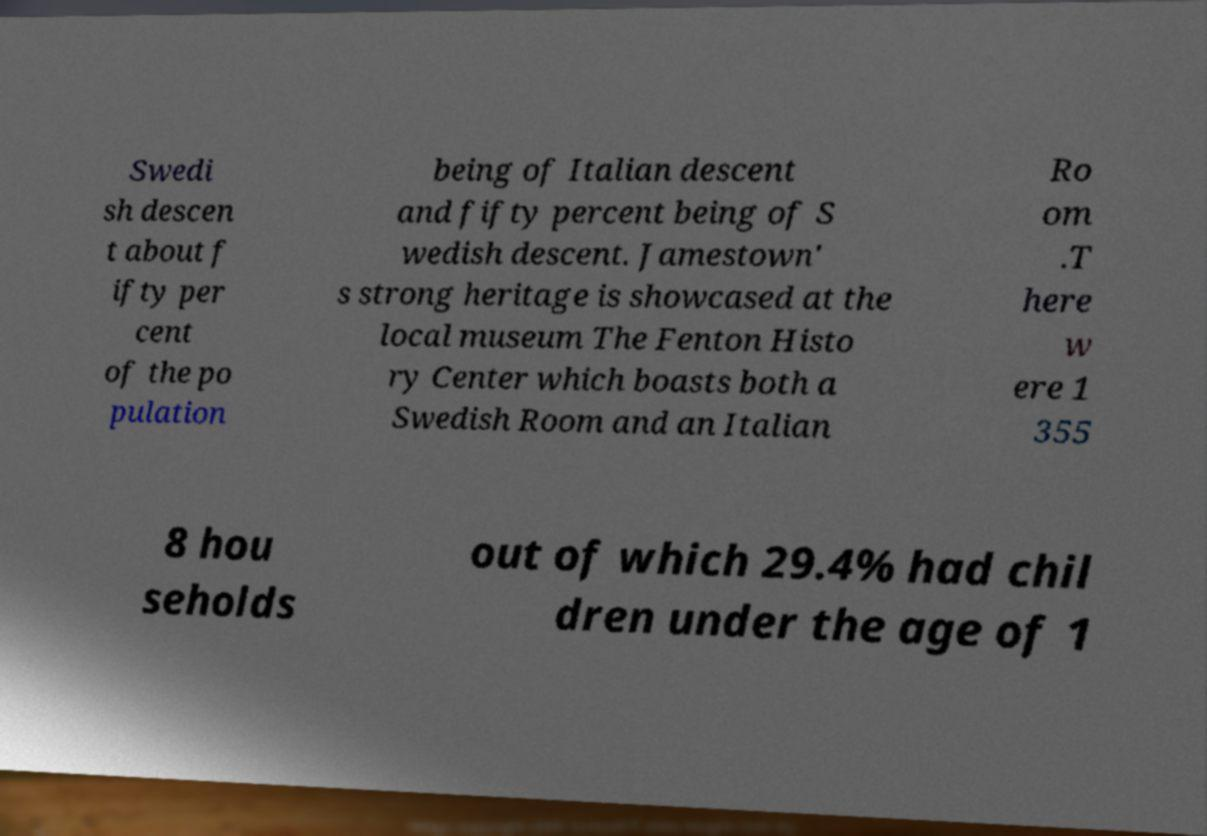Could you assist in decoding the text presented in this image and type it out clearly? Swedi sh descen t about f ifty per cent of the po pulation being of Italian descent and fifty percent being of S wedish descent. Jamestown' s strong heritage is showcased at the local museum The Fenton Histo ry Center which boasts both a Swedish Room and an Italian Ro om .T here w ere 1 355 8 hou seholds out of which 29.4% had chil dren under the age of 1 